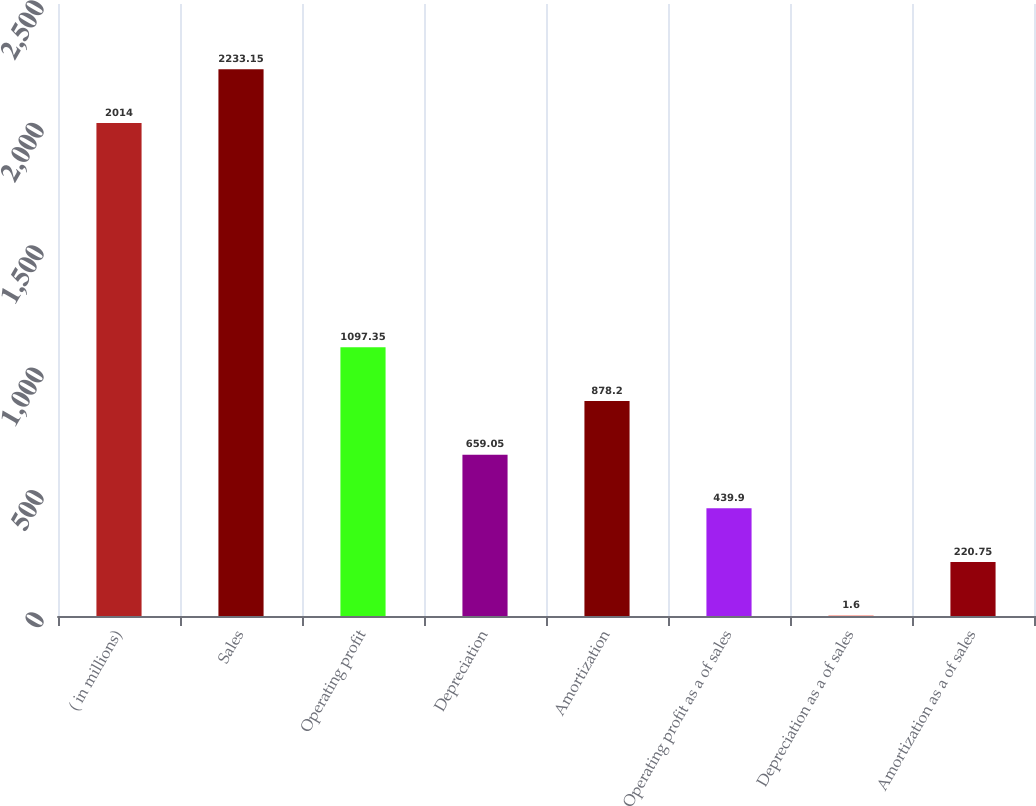<chart> <loc_0><loc_0><loc_500><loc_500><bar_chart><fcel>( in millions)<fcel>Sales<fcel>Operating profit<fcel>Depreciation<fcel>Amortization<fcel>Operating profit as a of sales<fcel>Depreciation as a of sales<fcel>Amortization as a of sales<nl><fcel>2014<fcel>2233.15<fcel>1097.35<fcel>659.05<fcel>878.2<fcel>439.9<fcel>1.6<fcel>220.75<nl></chart> 